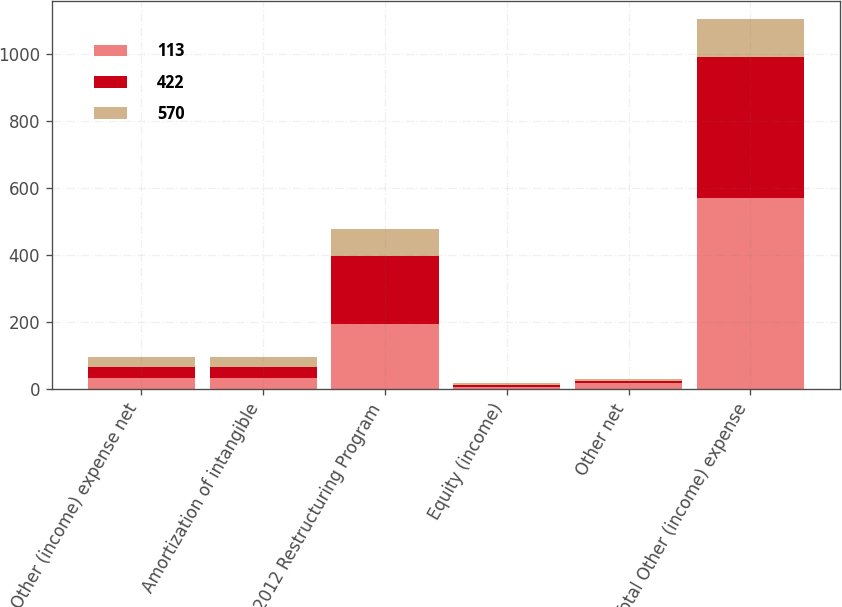Convert chart. <chart><loc_0><loc_0><loc_500><loc_500><stacked_bar_chart><ecel><fcel>Other (income) expense net<fcel>Amortization of intangible<fcel>2012 Restructuring Program<fcel>Equity (income)<fcel>Other net<fcel>Total Other (income) expense<nl><fcel>113<fcel>32<fcel>32<fcel>195<fcel>7<fcel>18<fcel>570<nl><fcel>422<fcel>32<fcel>32<fcel>202<fcel>5<fcel>5<fcel>422<nl><fcel>570<fcel>32<fcel>31<fcel>81<fcel>7<fcel>6<fcel>113<nl></chart> 